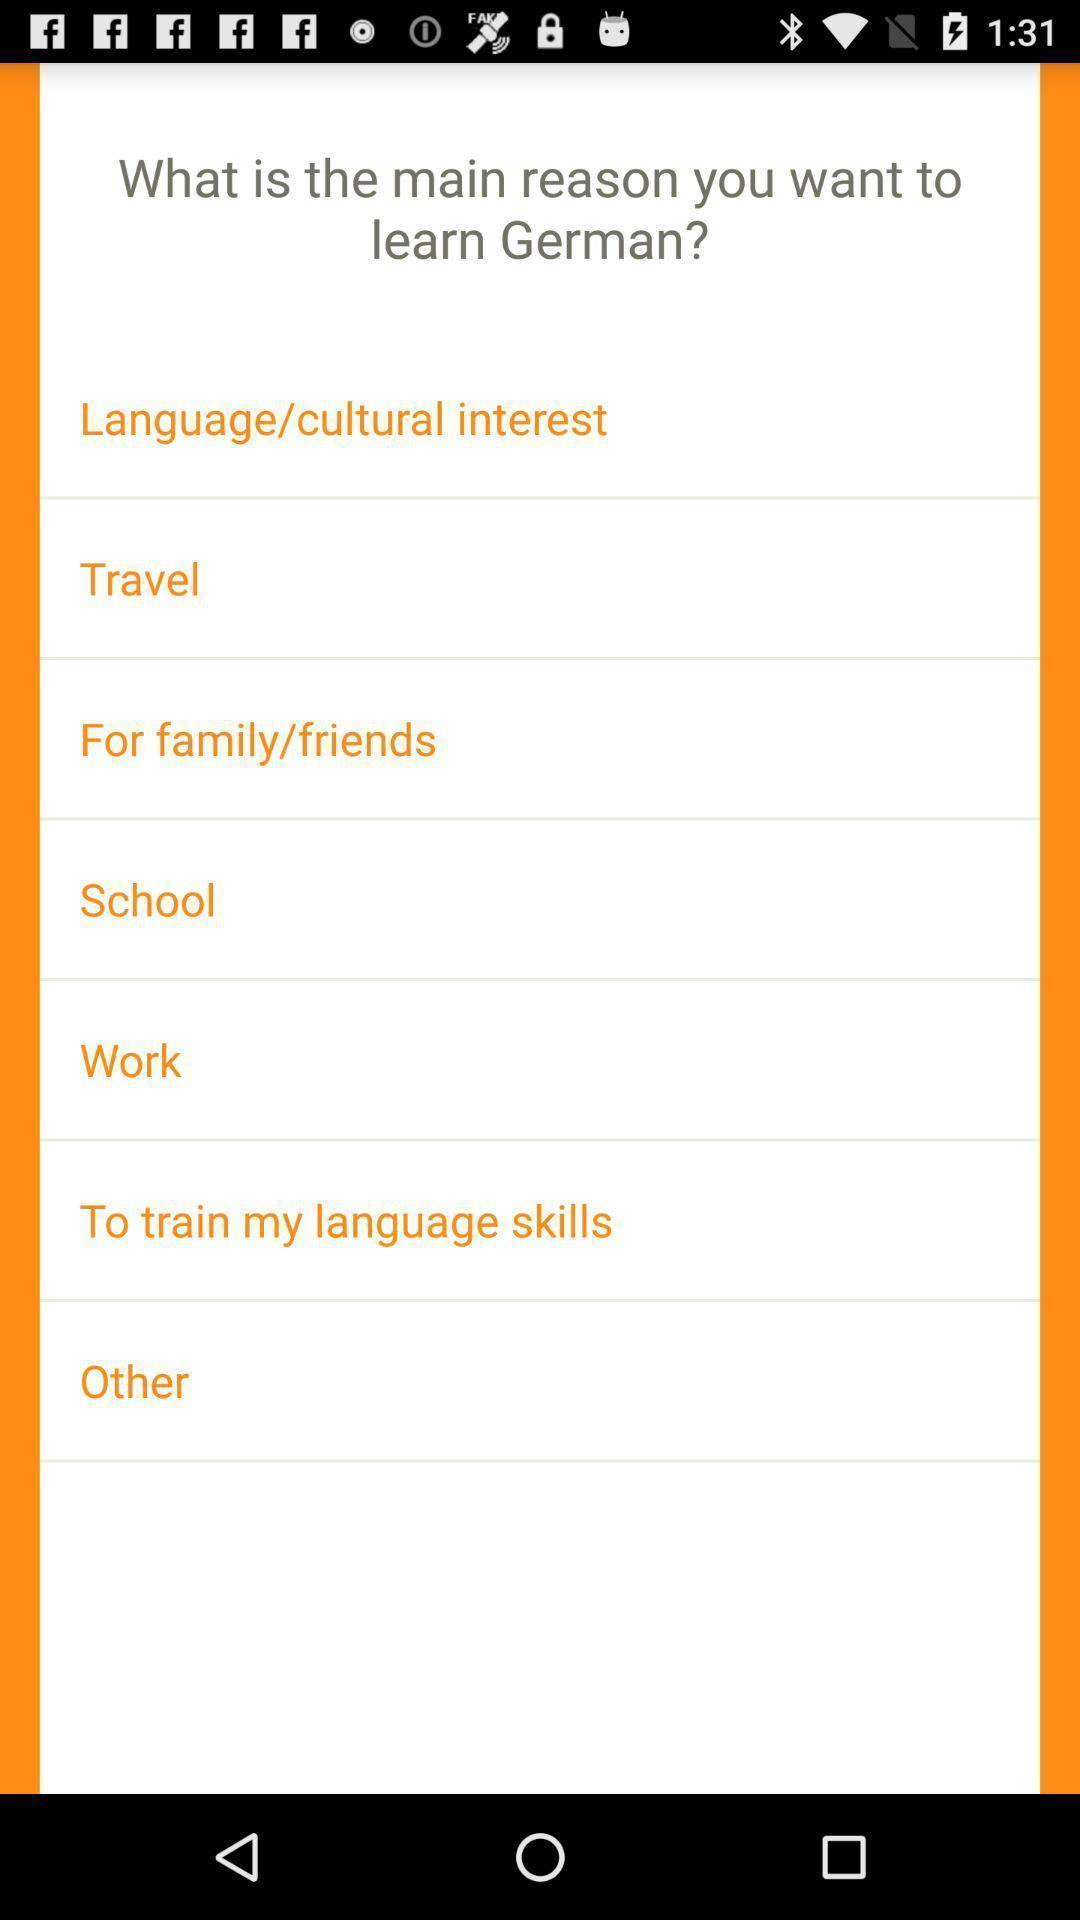Give me a narrative description of this picture. Screen shows different options. 